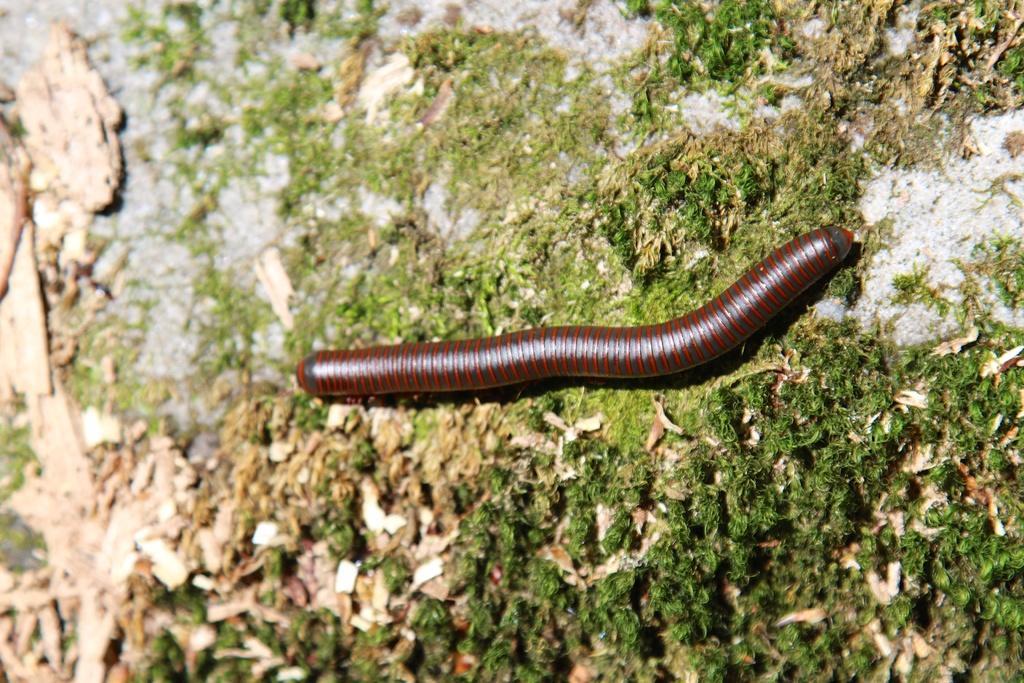Describe this image in one or two sentences. In this image, we can see a worm on the ground. 